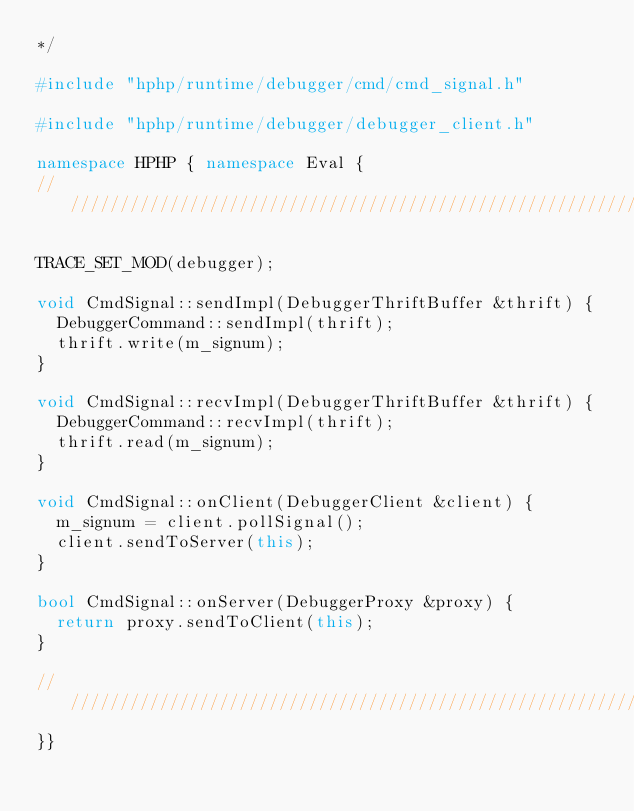<code> <loc_0><loc_0><loc_500><loc_500><_C++_>*/

#include "hphp/runtime/debugger/cmd/cmd_signal.h"

#include "hphp/runtime/debugger/debugger_client.h"

namespace HPHP { namespace Eval {
///////////////////////////////////////////////////////////////////////////////

TRACE_SET_MOD(debugger);

void CmdSignal::sendImpl(DebuggerThriftBuffer &thrift) {
  DebuggerCommand::sendImpl(thrift);
  thrift.write(m_signum);
}

void CmdSignal::recvImpl(DebuggerThriftBuffer &thrift) {
  DebuggerCommand::recvImpl(thrift);
  thrift.read(m_signum);
}

void CmdSignal::onClient(DebuggerClient &client) {
  m_signum = client.pollSignal();
  client.sendToServer(this);
}

bool CmdSignal::onServer(DebuggerProxy &proxy) {
  return proxy.sendToClient(this);
}

///////////////////////////////////////////////////////////////////////////////
}}
</code> 